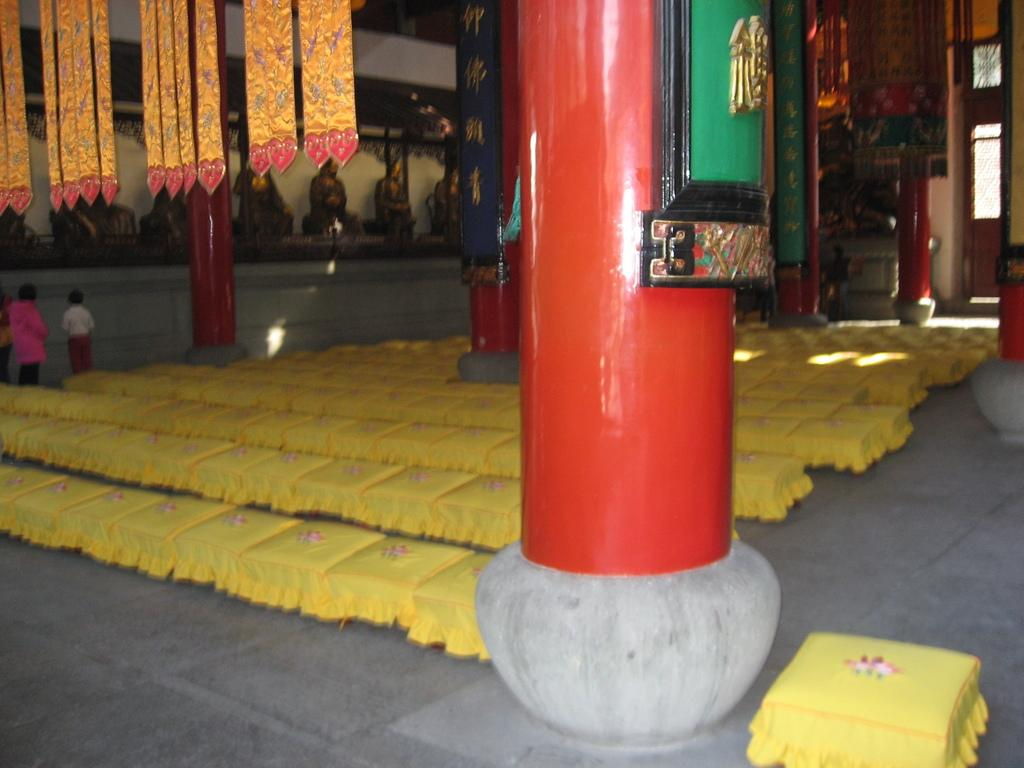What can be seen in the image involving human figures? There are people standing in the image. What are the people wearing? The people are wearing clothes. What architectural feature is present in the image? There is a pillar in the image. What surface is visible beneath the people? There is a floor visible in the image. What type of rifle can be seen in the hands of the people in the image? There is no rifle present in the image; the people are not holding any weapons. What color is the hair of the person standing on the left side of the image? There is no information about the color of the people's hair in the image, as the focus is on their clothing and the presence of a pillar and floor. 